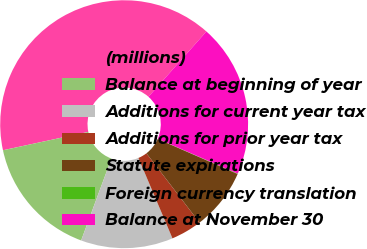Convert chart. <chart><loc_0><loc_0><loc_500><loc_500><pie_chart><fcel>(millions)<fcel>Balance at beginning of year<fcel>Additions for current year tax<fcel>Additions for prior year tax<fcel>Statute expirations<fcel>Foreign currency translation<fcel>Balance at November 30<nl><fcel>39.92%<fcel>15.99%<fcel>12.01%<fcel>4.03%<fcel>8.02%<fcel>0.05%<fcel>19.98%<nl></chart> 